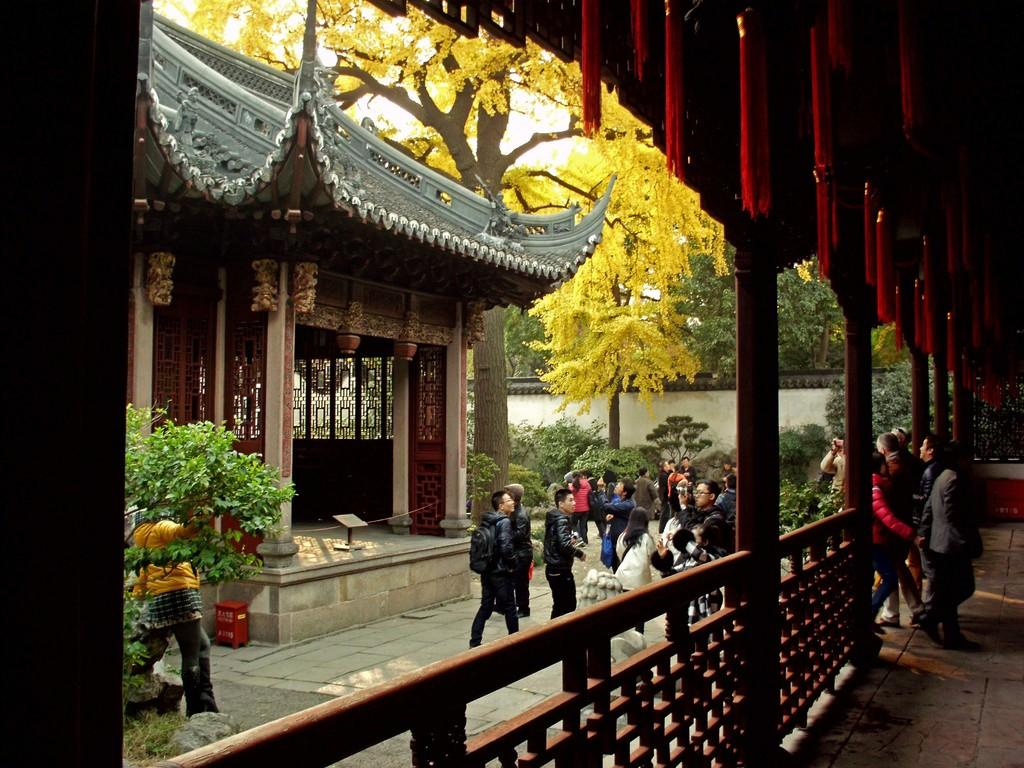What architectural features can be seen in the image? There are pillars and railings in the image. What natural elements are present in the image? There are trees and plants in the image. Are there any living beings in the image? Yes, there are people in the image. What type of structure is visible in the image? There is a house in the image. What additional objects can be seen in the image? There are decorative objects in the image. Can you tell me how many kittens are playing on the sun in the image? There are no kittens or sun present in the image. How many ladybugs can be seen crawling on the plants in the image? There is no mention of ladybugs in the image, so we cannot determine their presence or quantity. 